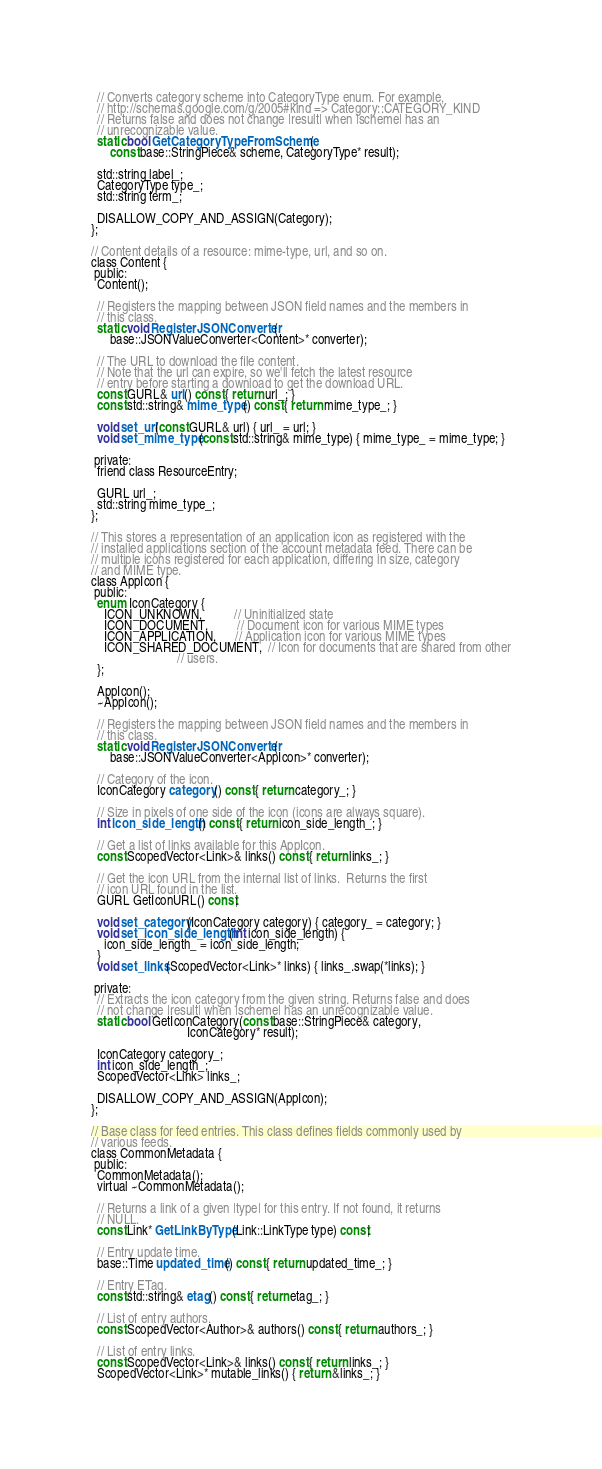<code> <loc_0><loc_0><loc_500><loc_500><_C_>  // Converts category scheme into CategoryType enum. For example,
  // http://schemas.google.com/g/2005#kind => Category::CATEGORY_KIND
  // Returns false and does not change |result| when |scheme| has an
  // unrecognizable value.
  static bool GetCategoryTypeFromScheme(
      const base::StringPiece& scheme, CategoryType* result);

  std::string label_;
  CategoryType type_;
  std::string term_;

  DISALLOW_COPY_AND_ASSIGN(Category);
};

// Content details of a resource: mime-type, url, and so on.
class Content {
 public:
  Content();

  // Registers the mapping between JSON field names and the members in
  // this class.
  static void RegisterJSONConverter(
      base::JSONValueConverter<Content>* converter);

  // The URL to download the file content.
  // Note that the url can expire, so we'll fetch the latest resource
  // entry before starting a download to get the download URL.
  const GURL& url() const { return url_; }
  const std::string& mime_type() const { return mime_type_; }

  void set_url(const GURL& url) { url_ = url; }
  void set_mime_type(const std::string& mime_type) { mime_type_ = mime_type; }

 private:
  friend class ResourceEntry;

  GURL url_;
  std::string mime_type_;
};

// This stores a representation of an application icon as registered with the
// installed applications section of the account metadata feed. There can be
// multiple icons registered for each application, differing in size, category
// and MIME type.
class AppIcon {
 public:
  enum IconCategory {
    ICON_UNKNOWN,          // Uninitialized state
    ICON_DOCUMENT,         // Document icon for various MIME types
    ICON_APPLICATION,      // Application icon for various MIME types
    ICON_SHARED_DOCUMENT,  // Icon for documents that are shared from other
                           // users.
  };

  AppIcon();
  ~AppIcon();

  // Registers the mapping between JSON field names and the members in
  // this class.
  static void RegisterJSONConverter(
      base::JSONValueConverter<AppIcon>* converter);

  // Category of the icon.
  IconCategory category() const { return category_; }

  // Size in pixels of one side of the icon (icons are always square).
  int icon_side_length() const { return icon_side_length_; }

  // Get a list of links available for this AppIcon.
  const ScopedVector<Link>& links() const { return links_; }

  // Get the icon URL from the internal list of links.  Returns the first
  // icon URL found in the list.
  GURL GetIconURL() const;

  void set_category(IconCategory category) { category_ = category; }
  void set_icon_side_length(int icon_side_length) {
    icon_side_length_ = icon_side_length;
  }
  void set_links(ScopedVector<Link>* links) { links_.swap(*links); }

 private:
  // Extracts the icon category from the given string. Returns false and does
  // not change |result| when |scheme| has an unrecognizable value.
  static bool GetIconCategory(const base::StringPiece& category,
                              IconCategory* result);

  IconCategory category_;
  int icon_side_length_;
  ScopedVector<Link> links_;

  DISALLOW_COPY_AND_ASSIGN(AppIcon);
};

// Base class for feed entries. This class defines fields commonly used by
// various feeds.
class CommonMetadata {
 public:
  CommonMetadata();
  virtual ~CommonMetadata();

  // Returns a link of a given |type| for this entry. If not found, it returns
  // NULL.
  const Link* GetLinkByType(Link::LinkType type) const;

  // Entry update time.
  base::Time updated_time() const { return updated_time_; }

  // Entry ETag.
  const std::string& etag() const { return etag_; }

  // List of entry authors.
  const ScopedVector<Author>& authors() const { return authors_; }

  // List of entry links.
  const ScopedVector<Link>& links() const { return links_; }
  ScopedVector<Link>* mutable_links() { return &links_; }
</code> 